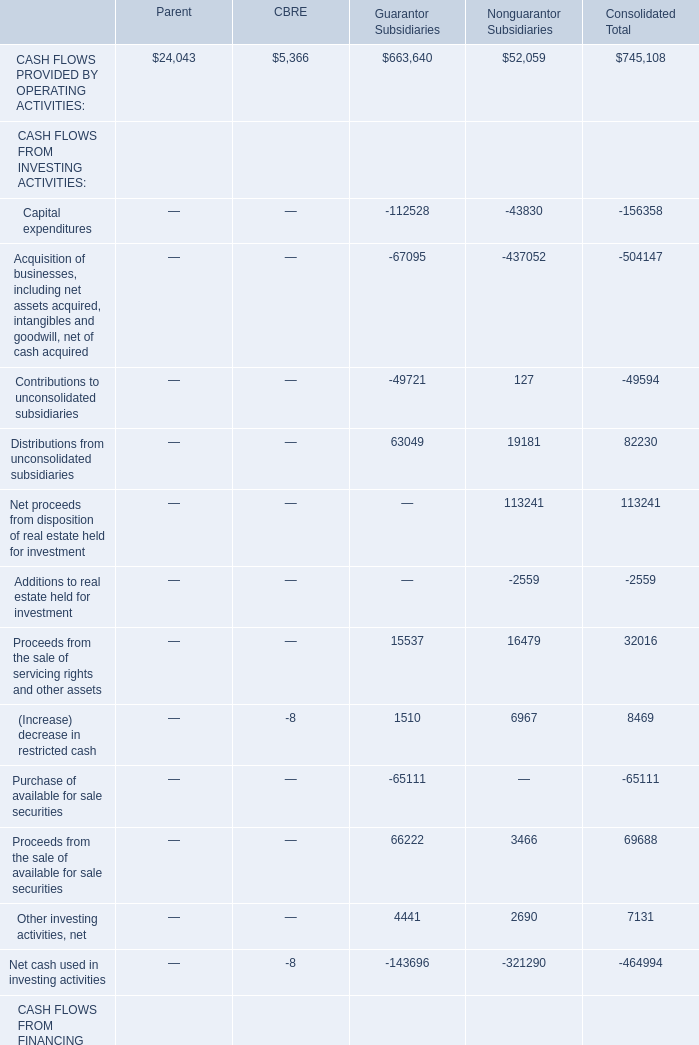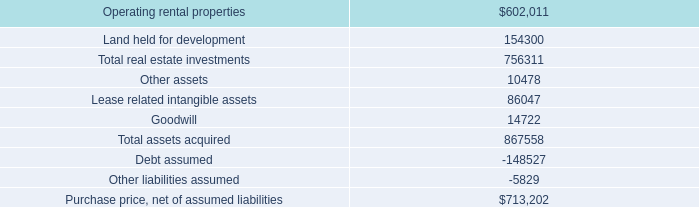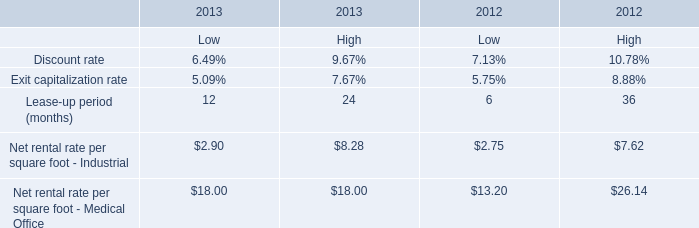What is the proportion of CASH FLOWS PROVIDED BY OPERATING ACTIVITIES of CBRE to the total in the year showed as table 1? 
Computations: (5366 / 745108)
Answer: 0.0072. 